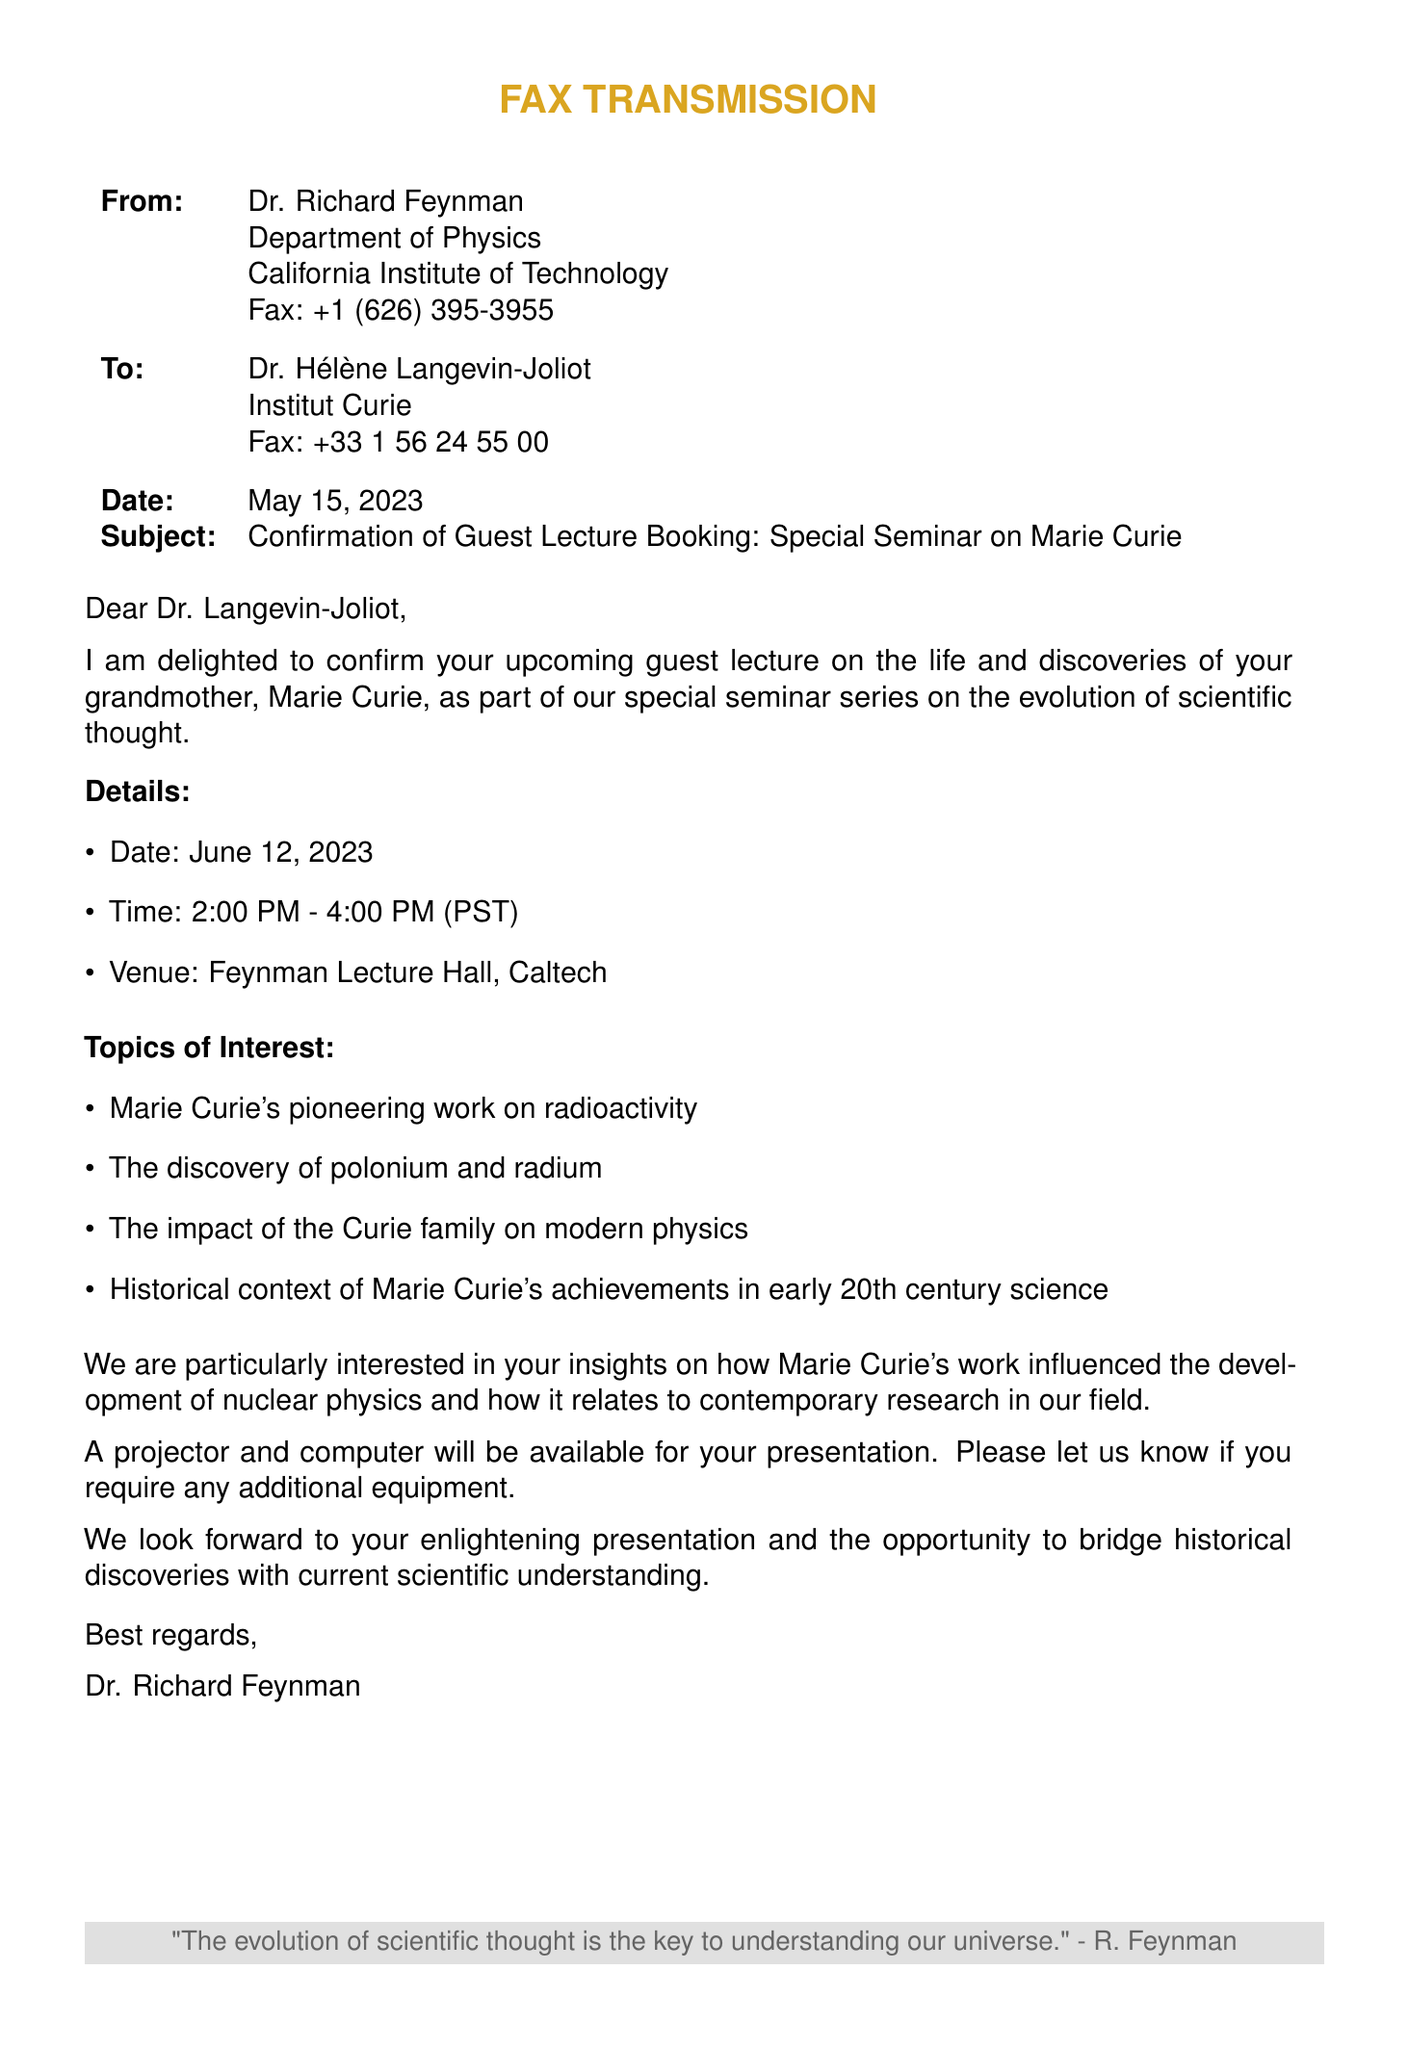What is the name of the guest lecturer? The guest lecturer confirmed in the document is Dr. Hélène Langevin-Joliot, who is the granddaughter of Marie Curie.
Answer: Dr. Hélène Langevin-Joliot What is the date of the seminar? The seminar is scheduled for June 12, 2023, as mentioned in the document under the details section.
Answer: June 12, 2023 What time is the guest lecture scheduled to start? The guest lecture is scheduled to begin at 2:00 PM, as stated in the details of the document.
Answer: 2:00 PM What topics will be discussed in the seminar? The seminar will cover topics including Marie Curie’s work on radioactivity and the discovery of polonium and radium, among others.
Answer: Radioactivity, polonium, radium What venue will host the seminar? The venue for the seminar is the Feynman Lecture Hall at Caltech, as specified in the document.
Answer: Feynman Lecture Hall, Caltech Who sent the fax? The sender of the fax is Dr. Richard Feynman from the California Institute of Technology.
Answer: Dr. Richard Feynman What additional equipment is mentioned for the presentation? The document states that a projector and computer will be available for the presentation.
Answer: Projector and computer What impact is the seminar concerned with regarding Marie Curie's work? The seminar is particularly interested in how Marie Curie's work influenced the development of nuclear physics and modern scientific understanding.
Answer: Nuclear physics What quote is included at the bottom of the fax? The quote included is, "The evolution of scientific thought is the key to understanding our universe." attributed to Richard Feynman.
Answer: "The evolution of scientific thought is the key to understanding our universe." 